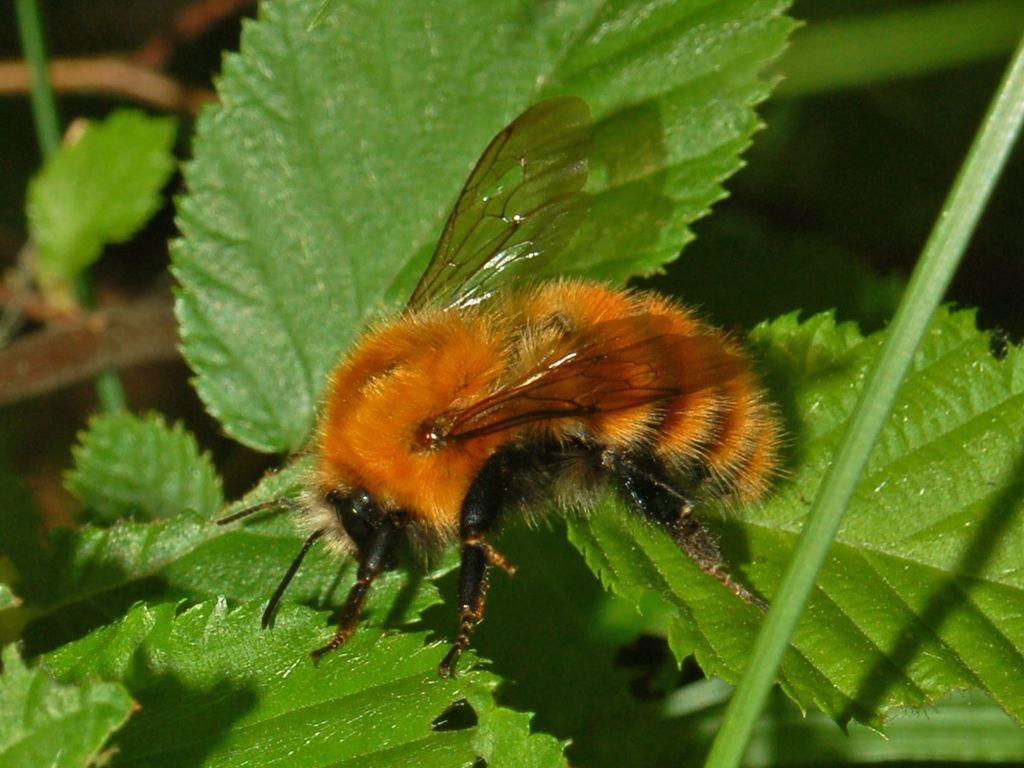What type of animal can be seen on the leaves in the image? There is a bee on the leaves in the image. What else can be seen on the right side of the image? There is a stem on the right side of the image. How would you describe the background of the image? The background of the image is blurred. What type of light source is illuminating the bee in the image? There is no specific light source mentioned or visible in the image, so it cannot be determined what type of light is illuminating the bee. 